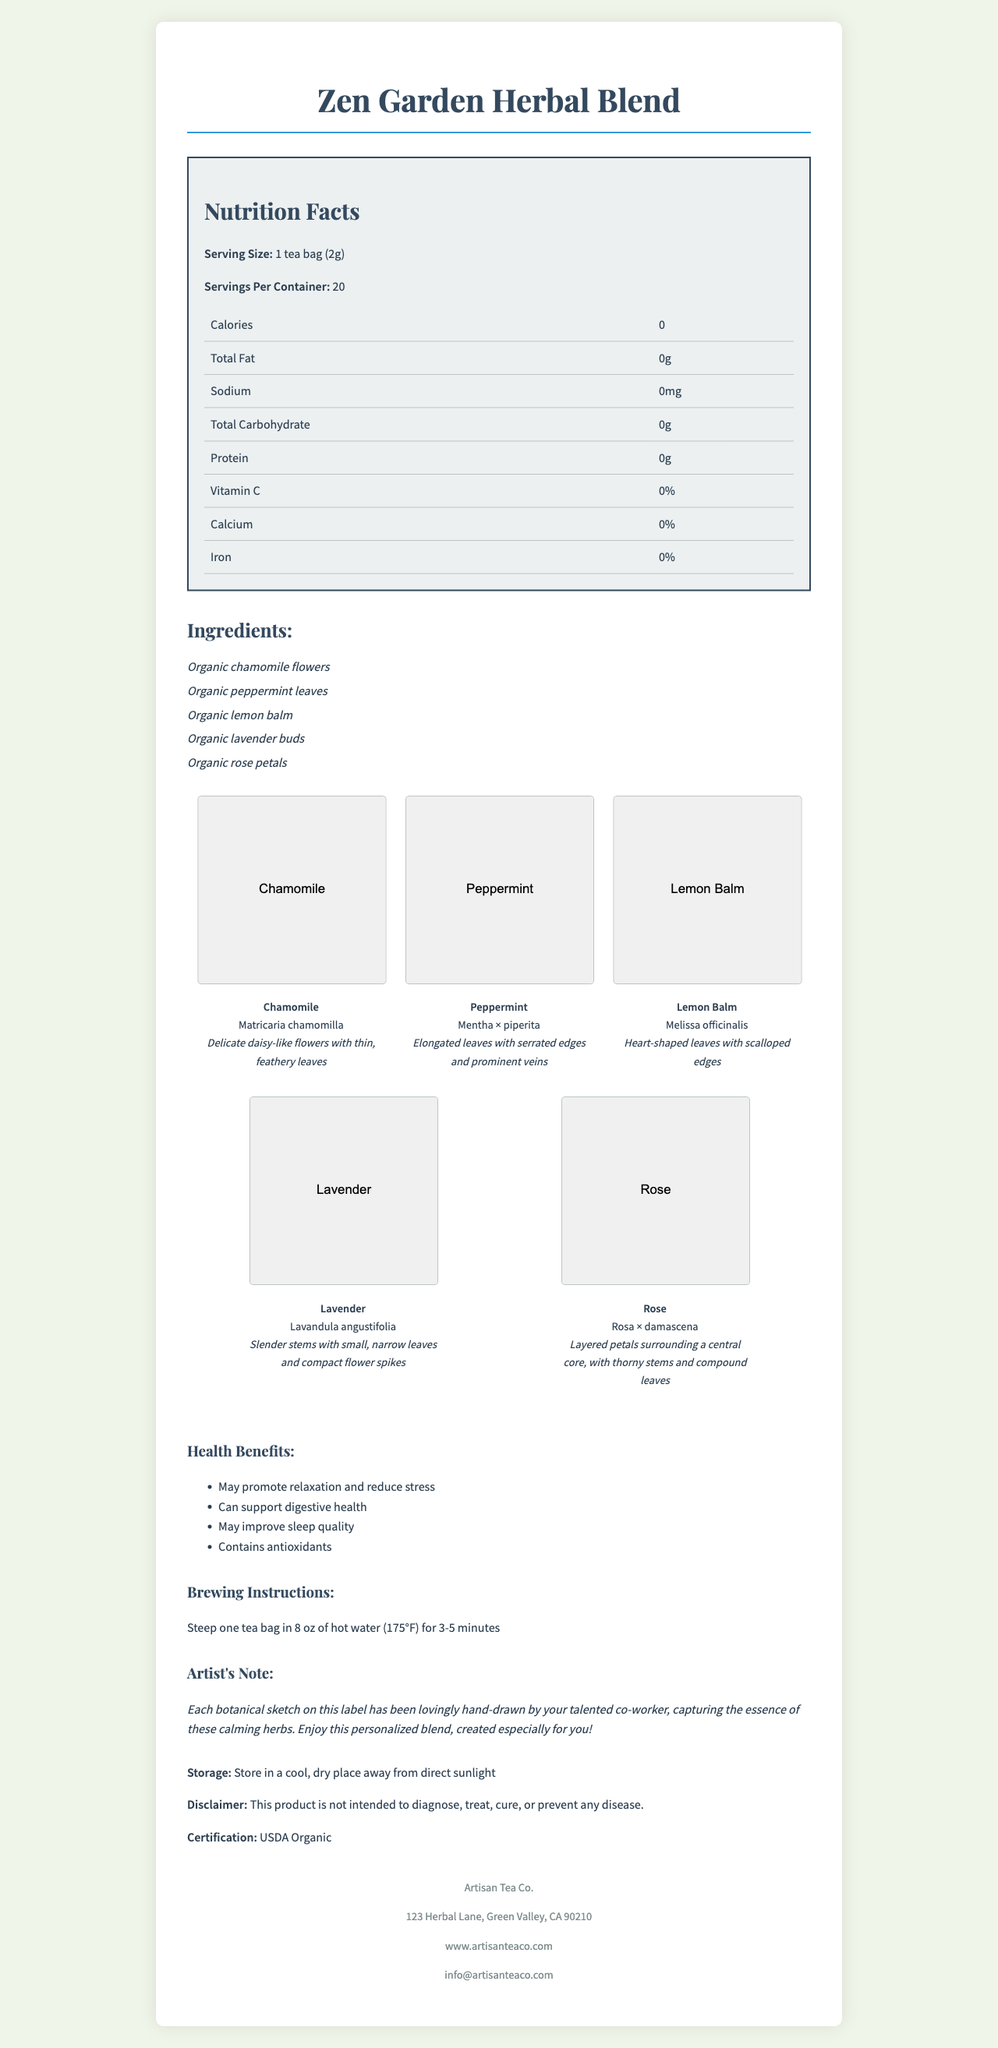what is the serving size for "Zen Garden Herbal Blend"? The serving size is explicitly mentioned in the nutrition facts section.
Answer: 1 tea bag (2g) how many servings are there per container? The document states that there are 20 servings per container.
Answer: 20 what is the calorie content per serving? The nutrition facts indicate the calorie content as 0 per serving.
Answer: 0 what kind of certification does this herbal blend have? The certification section mentions "USDA Organic."
Answer: USDA Organic what are the primary ingredients in this tea? The ingredients list includes these five herbs.
Answer: Organic chamomile flowers, Organic peppermint leaves, Organic lemon balm, Organic lavender buds, Organic rose petals what iconic feature is highlighted in chamomile's botanical sketch? A. Elongated leaves B. Daisy-like flowers C. Compact flower spikes D. Thorny stems The sketch description for chamomile mentions "Delicate daisy-like flowers with thin, feathery leaves."
Answer: B how long should one steep the tea for? A. 1-2 minutes B. 3-5 minutes C. 5-7 minutes D. 8-10 minutes The brewing instructions state to steep the tea for 3-5 minutes.
Answer: B does this herbal tea contain any protein? The nutrition facts indicate that the protein content is 0g.
Answer: No is there any sodium in the "Zen Garden Herbal Blend"? The nutrition facts list the sodium content as 0mg.
Answer: No summarize the main idea of the document. The document provides comprehensive information about the herbal tea's ingredients, nutritional facts, health benefits, and brewing instructions, accompanied by artistic sketches of the included herbs.
Answer: A detailed nutritional breakdown and artistic description of the "Zen Garden Herbal Blend" tea, including its ingredients, health benefits, and preparation instructions, along with artistic botanical sketches. which company manufactures this herbal blend? The company information at the bottom of the document lists Artisan Tea Co. as the manufacturer.
Answer: Artisan Tea Co. what is the Latin name for lavender as shown in the botanical sketches section? The botanical sketches section lists "Lavandula angustifolia" as the Latin name for lavender.
Answer: Lavandula angustifolia is this herbal blend designed to diagnose, treat, cure, or prevent any disease? The disclaimer at the end of the document states that this product is not intended to diagnose, treat, cure, or prevent any disease.
Answer: No are there any vitamins provided in this herbal blend? The nutrition facts indicate 0% for vitamin C, calcium, and iron.
Answer: No describe the artist's note included in the document. The artist's note section explains the personal touch and effort put into the botanical sketches and the creation of the herbal blend for the reader.
Answer: The artist's note expresses that the botanical sketches on the label were hand-drawn by the reader's talented co-worker, capturing the essence of the calming herbs, and notes that the blend was created especially for the reader. can you determine the exact temperature of the water to use for steeping the tea? The brewing instructions specify to use water at 175°F for steeping the tea.
Answer: Yes, 175°F 